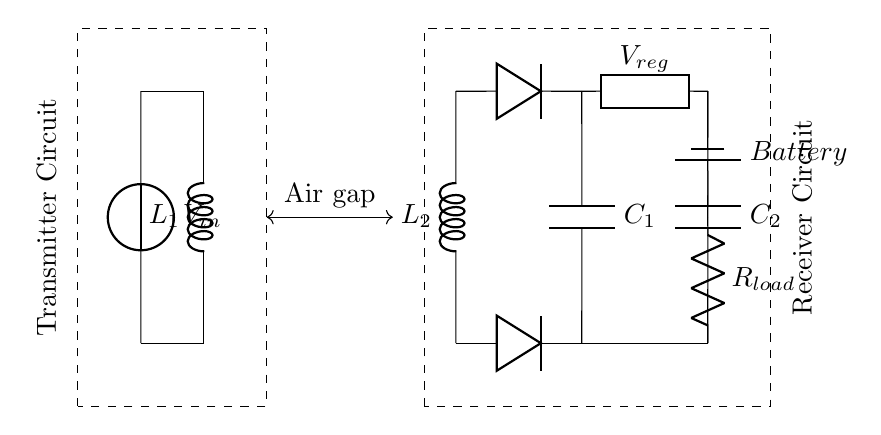What is the primary component in the transmitter circuit? The primary component is the inductor labeled L1, which is used to create the magnetic field necessary for induction.
Answer: L1 How many diodes are present in the receiver circuit? There are two diodes used for rectification to convert AC to DC. They are positioned in the upper and lower paths from the secondary coil.
Answer: 2 What does the air gap represent in this circuit? The air gap is the separation between the primary and secondary coils that allows for magnetic field induction without physical contact.
Answer: Induction What is the purpose of capacitor C1 in the circuit? Capacitor C1 functions as a filter to smooth out the rectified voltage, reducing fluctuations in the DC output voltage.
Answer: Filtering Which component regulates the voltage in the receiver circuit? The component that regulates the voltage in the receiver circuit is the generic component labeled V_reg, ensuring a stable output voltage for the load.
Answer: V_reg How is the load connected to the battery in this circuit? The load is connected in series to the battery, which allows it to receive power after the voltage has been regulated.
Answer: Series connection 